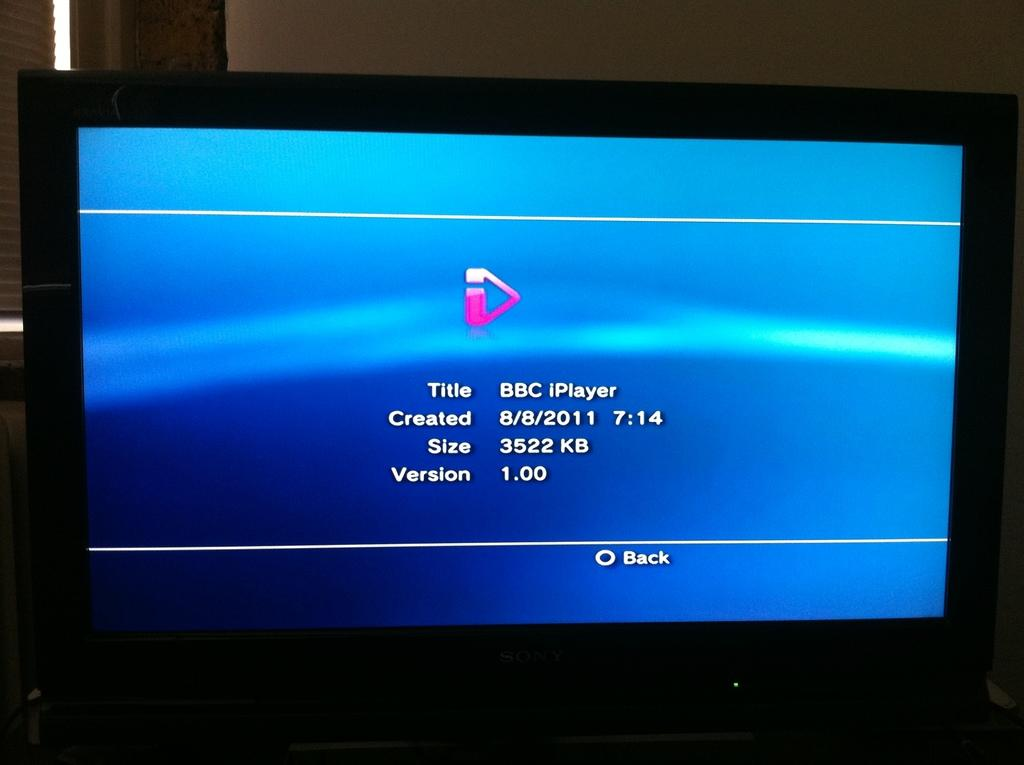<image>
Render a clear and concise summary of the photo. A TV screen displays information for an app called BBC iPlayer, which is version 1.00 